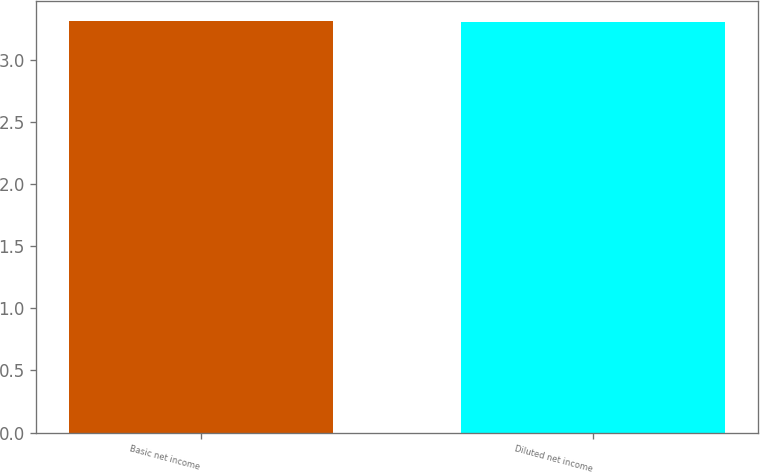Convert chart to OTSL. <chart><loc_0><loc_0><loc_500><loc_500><bar_chart><fcel>Basic net income<fcel>Diluted net income<nl><fcel>3.31<fcel>3.3<nl></chart> 